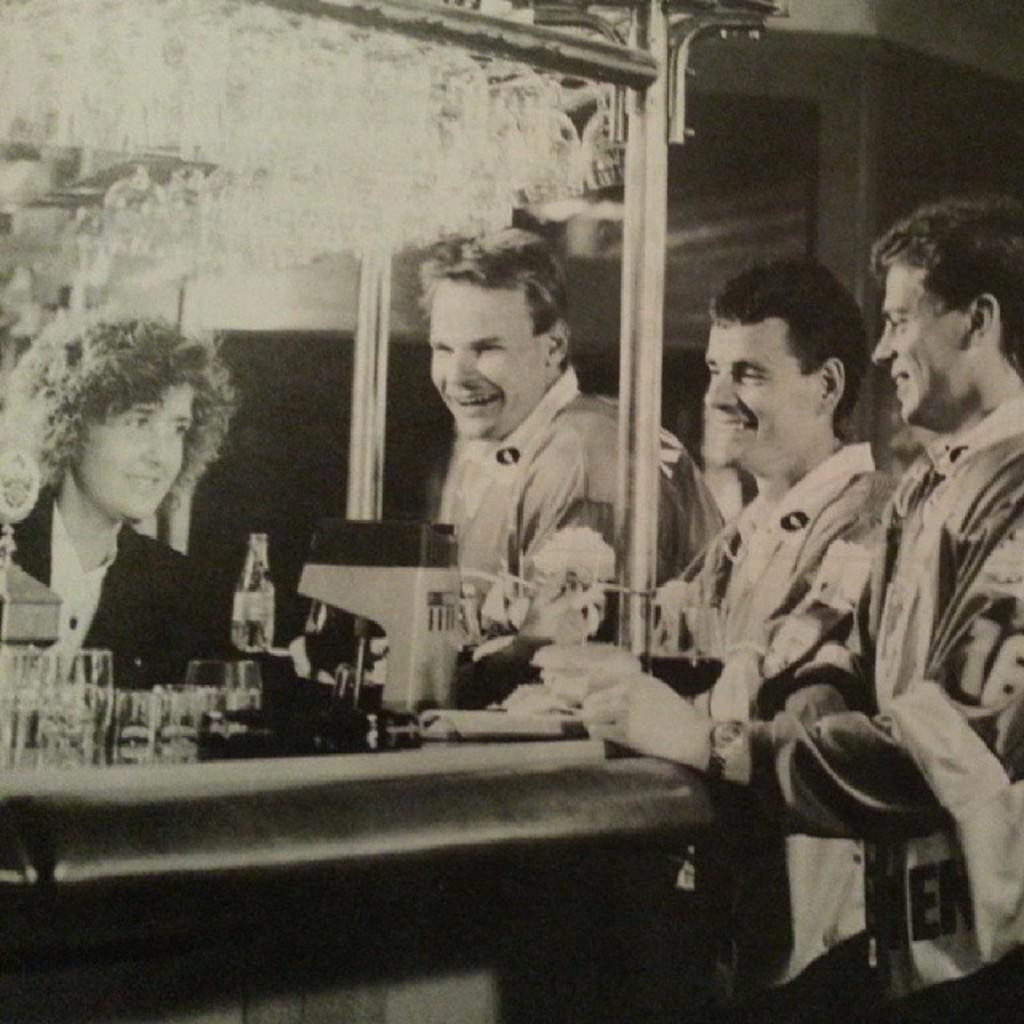What is the color scheme of the image? The image is black and white. What can be seen in the image besides the color scheme? There are people in the image, and they are smiling. What is present on the table in the image? There is a table in the image, and on it, there are glasses, a bottle, and other unspecified things. Can you tell me how many rings are on the table in the image? There is no mention of rings in the image, so it is impossible to determine their presence or quantity. What type of berry can be seen on the table in the image? There is no mention of any berries in the image; only glasses, a bottle, and other unspecified items are present on the table. 